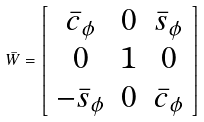<formula> <loc_0><loc_0><loc_500><loc_500>\bar { W } = \left [ \begin{array} { c c c } \bar { c } _ { \phi } & 0 & \bar { s } _ { \phi } \\ 0 & 1 & 0 \\ - \bar { s } _ { \phi } & 0 & \bar { c } _ { \phi } \end{array} \right ]</formula> 